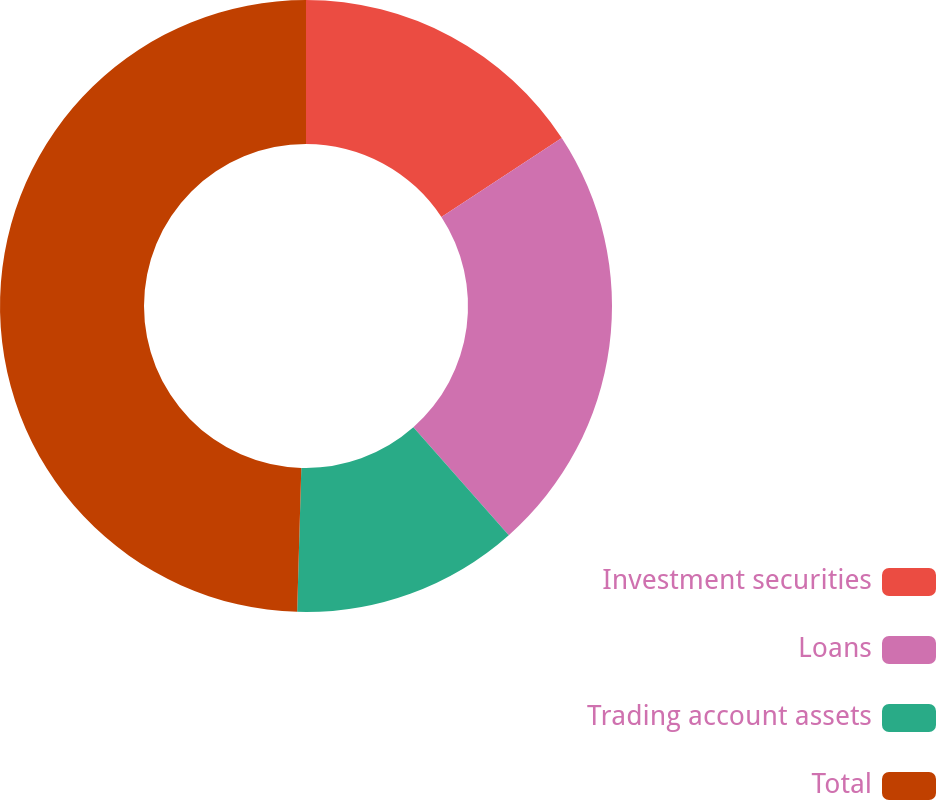<chart> <loc_0><loc_0><loc_500><loc_500><pie_chart><fcel>Investment securities<fcel>Loans<fcel>Trading account assets<fcel>Total<nl><fcel>15.75%<fcel>22.72%<fcel>11.99%<fcel>49.54%<nl></chart> 